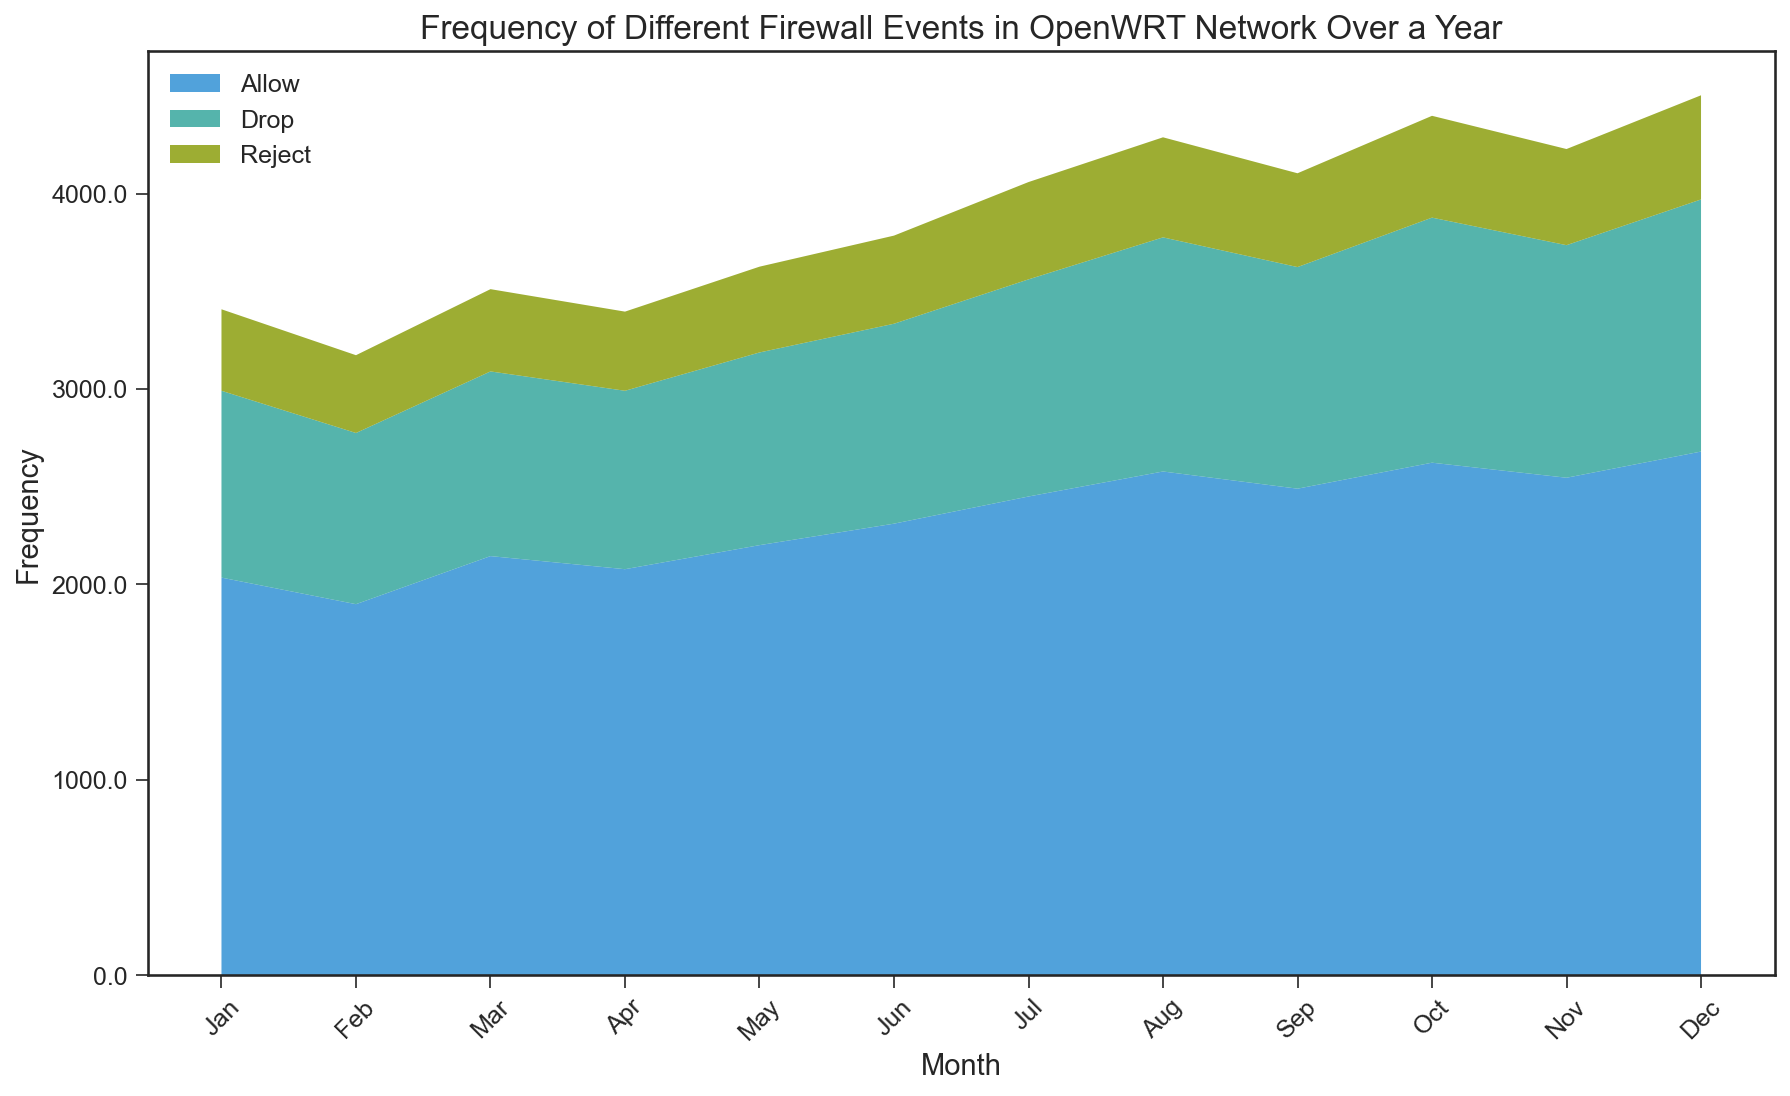Which month had the highest frequency of 'Allow' events? To determine which month had the highest frequency of 'Allow' events, look at the values of 'Allow' for each month. The value for December is the highest at 2680.
Answer: December What is the difference in 'Reject' event frequencies between August and February? To calculate the difference, subtract the frequency of 'Reject' events in February (398) from that in August (512). 512 - 398 = 114.
Answer: 114 How do the total frequencies of 'Drop' events in the first half of the year (Jan-Jun) compare to the second half (Jul-Dec)? Sum the 'Drop' event frequencies for January to June: 956 + 876 + 945 + 913 + 986 + 1023 = 5699. Then sum for July to December: 1111 + 1198 + 1134 + 1254 + 1190 + 1290 = 7177. Compare the sums: 5699 vs 7177. The second half has higher frequencies.
Answer: Second half is higher In which month were the 'Drop' events lower than both 'Allow' and 'Reject' events? Examine each month to see if 'Drop' is lower than both 'Allow' and 'Reject'. In no month is 'Drop' lower than both 'Allow' and 'Reject'.
Answer: None Which event type ('Allow', 'Drop', 'Reject') saw the most consistent frequency across all months? Check the range of values for each event type across all months. 'Reject' events range from 398 to 533, which is the smallest range compared to 'Allow' (1899 to 2680) and 'Drop' (876 to 1290).
Answer: Reject What is the average frequency of 'Allow' events in the second half of the year (Jul-Dec)? Sum the 'Allow' frequencies from July to December: 2450 + 2578 + 2490 + 2623 + 2546 + 2680 = 15367. Divide by 6 months: 15367 / 6 ≈ 2561.17.
Answer: 2561.17 Which month experienced the highest combined frequency of all event types? For each month, sum the 'Allow', 'Drop', and 'Reject' frequencies. December has the highest combined frequency: 2680 + 1290 + 533 = 4503.
Answer: December How do the trends in 'Allow' events and 'Drop' events compare over the year? Review the trends of 'Allow' and 'Drop' events month by month. Both show a general increasing trend from January to December.
Answer: Both increase What is the difference in the total number of 'Drop' and 'Reject' events over the entire year? Sum the total number of 'Drop' events: 11274. Sum the total number of 'Reject' events: 5567. The difference is 11274 - 5567 = 5707.
Answer: 5707 